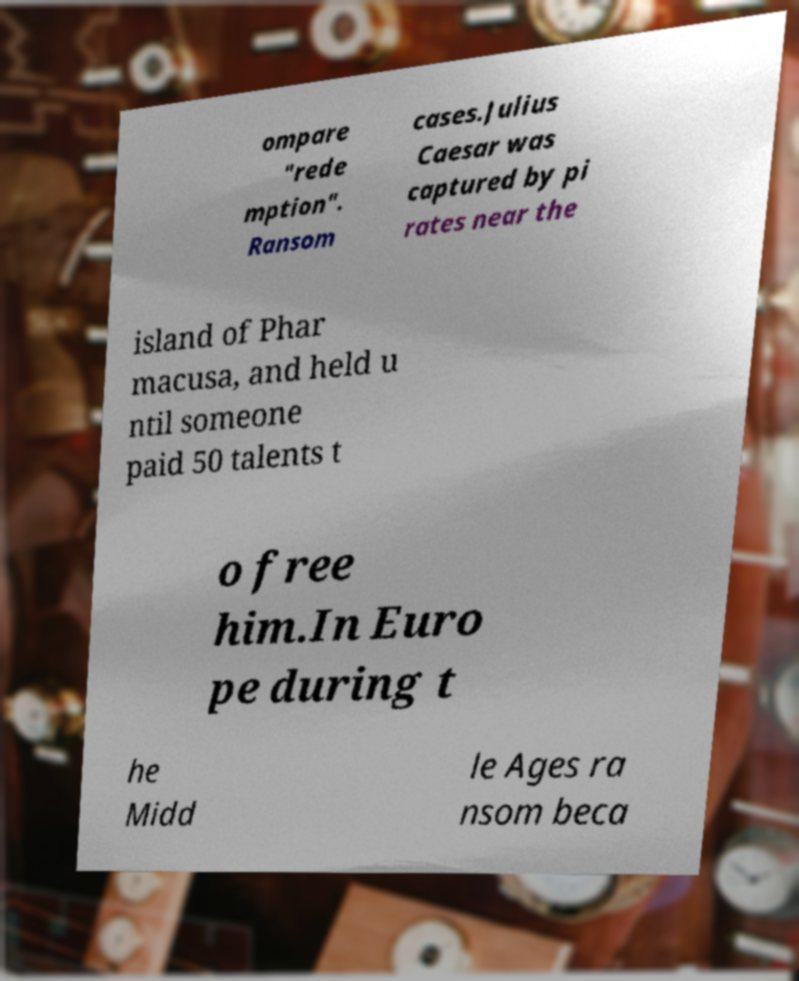Can you read and provide the text displayed in the image?This photo seems to have some interesting text. Can you extract and type it out for me? ompare "rede mption". Ransom cases.Julius Caesar was captured by pi rates near the island of Phar macusa, and held u ntil someone paid 50 talents t o free him.In Euro pe during t he Midd le Ages ra nsom beca 